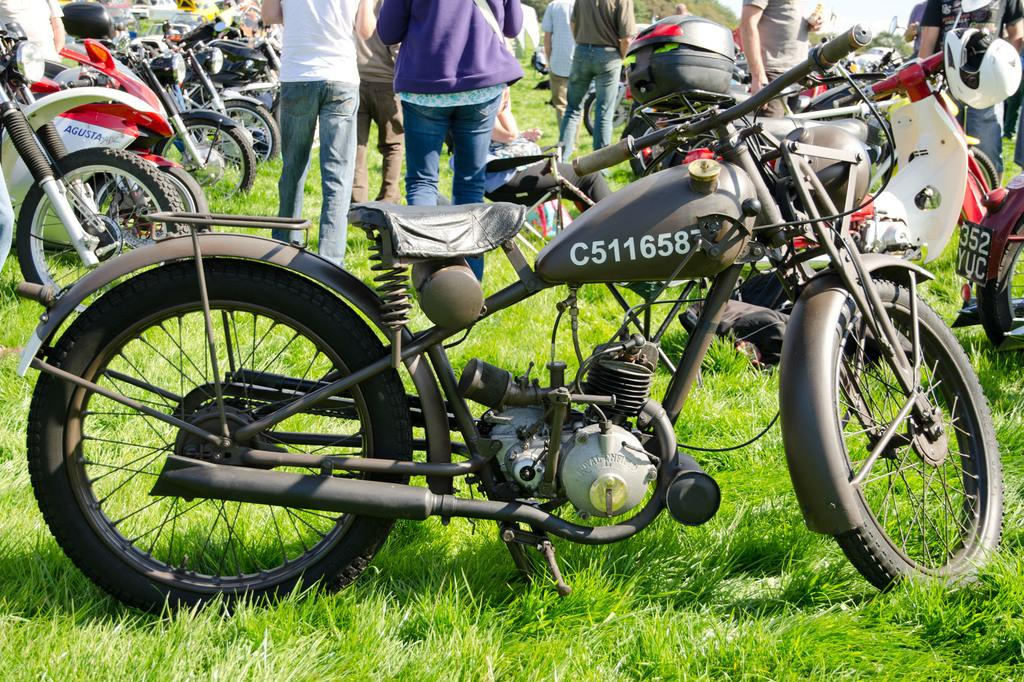What type of vehicles are present in the image? There are bicycles in the image. What are the people in the image doing? There are people walking in the image. What is the profit margin of the bicycles in the image? There is no information about the profit margin of the bicycles in the image. Can you tell me how many grapes are visible in the image? There are no grapes present in the image. 